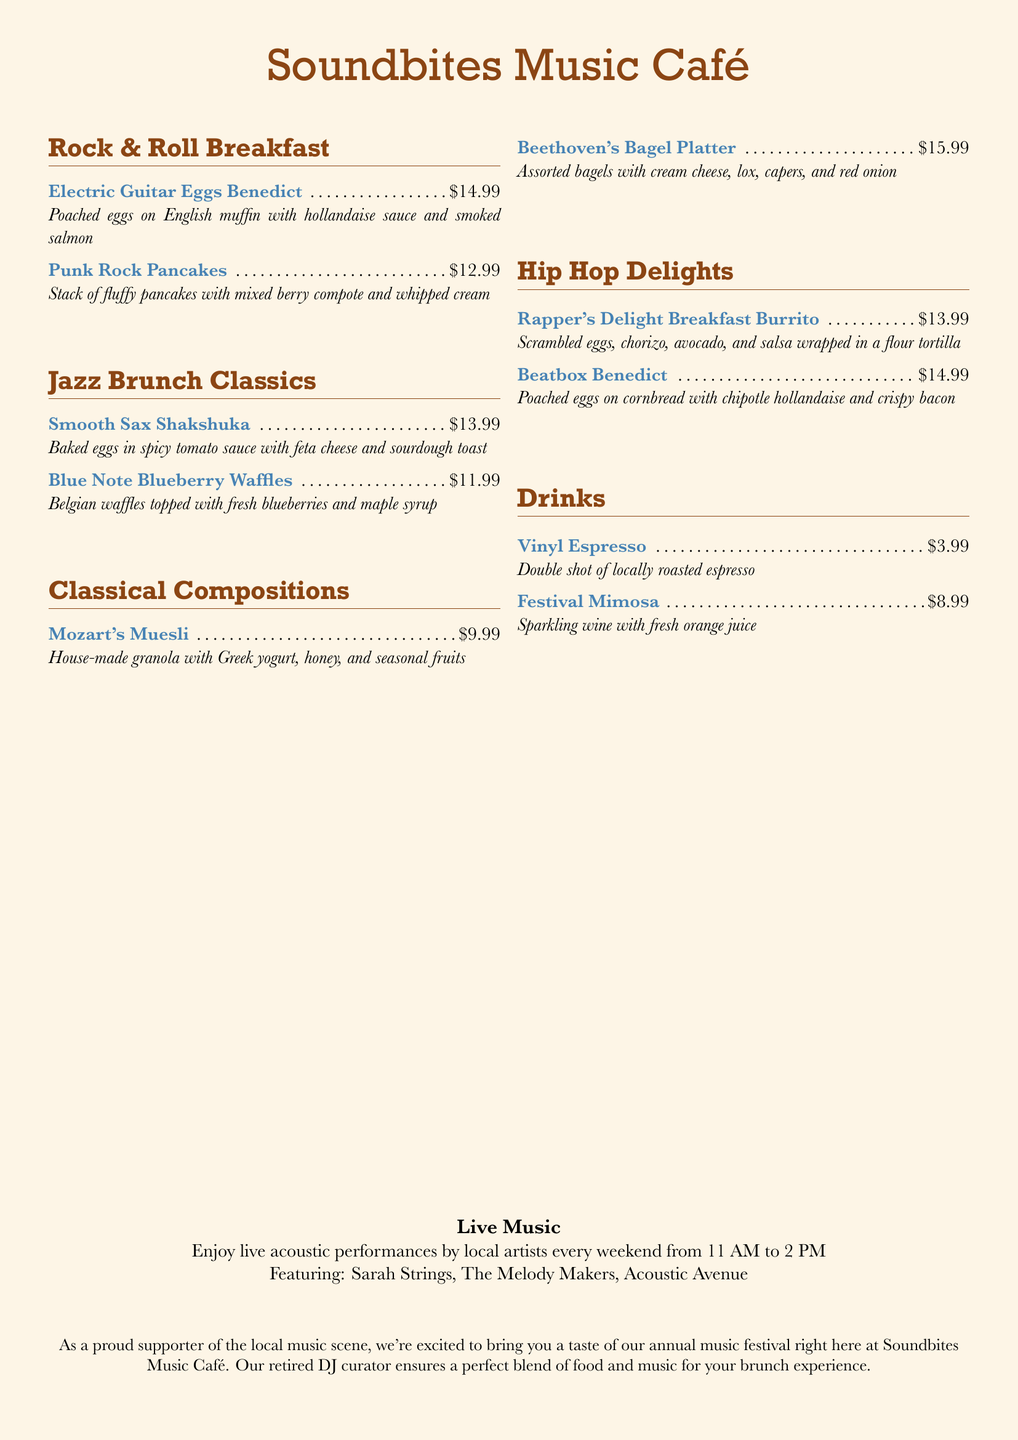What is the name of the café? The name of the café is featured at the top of the document.
Answer: Soundbites Music Café What is the price of Electric Guitar Eggs Benedict? The price is listed next to the dish in the menu section.
Answer: $14.99 Which dish is served with mixed berry compote? The dish is found in the Rock & Roll Breakfast section of the menu.
Answer: Punk Rock Pancakes What type of drink is the Festival Mimosa? The drink is described in the Drinks section of the menu.
Answer: Sparkling wine with fresh orange juice When is live music performed? The schedule for live music is mentioned at the bottom of the document.
Answer: Every weekend from 11 AM to 2 PM Who curates the music experience at the café? The information is included in the last paragraph of the document.
Answer: Retired DJ curator What is included in the Beethoven's Bagel Platter? The ingredients are listed for the dish in the Classical Compositions section.
Answer: Assorted bagels with cream cheese, lox, capers, and red onion How much is a double shot of locally roasted espresso? The price is provided in the Drinks section of the menu.
Answer: $3.99 What is the signature dish for Jazz Brunch Classics? The dish name is provided at the start of its own section in the menu.
Answer: Smooth Sax Shakshuka 